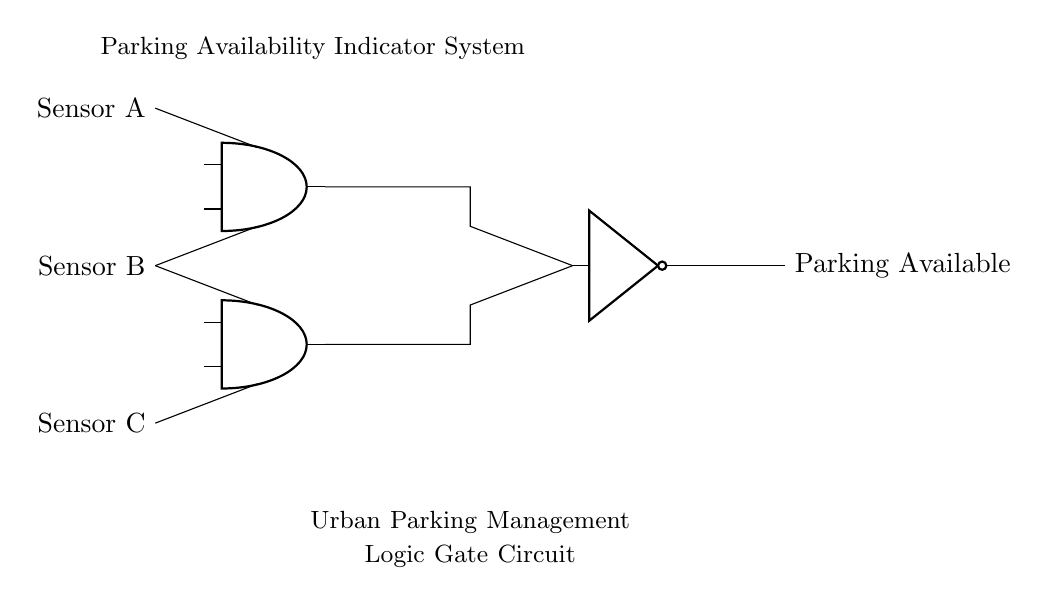What do the sensors represent in this circuit? The sensors represent the different parking spots monitored for availability. Sensor A, B, and C correspond to individual parking spaces connected to the logic gates to determine occupancy.
Answer: Parking spots What is the function of the AND gates in the circuit? The AND gates process the input signals from the sensors and output a high signal only when both inputs are high, indicating that specific conditions for parking availability are met.
Answer: To process input signals What is the output of the NOT gate called? The output of the NOT gate provides the final indication of parking availability by inverting the signal from the AND gates, meaning it indicates when parking spots are available.
Answer: Parking Available How many sensors are connected to the AND gates? There are three sensors connected, with two sensors feeding into each AND gate to evaluate parking space availability collectively.
Answer: Three Why are there two AND gates in the circuit? The two AND gates allow for evaluating different combinations of sensor inputs to effectively indicate parking availability based on specific criteria, improving decision-making capabilities for parking management.
Answer: To evaluate combinations If all sensors are unavailable, what will the output state be? If all sensors indicate unavailability, the AND gates will output low signals, leading the NOT gate to output a signal indicating no parking availability.
Answer: No parking available What does the label say at the top of the circuit? The label states the purpose of the circuit, indicating that it is a "Parking Availability Indicator System" which contributes to urban parking management strategies.
Answer: Parking Availability Indicator System 